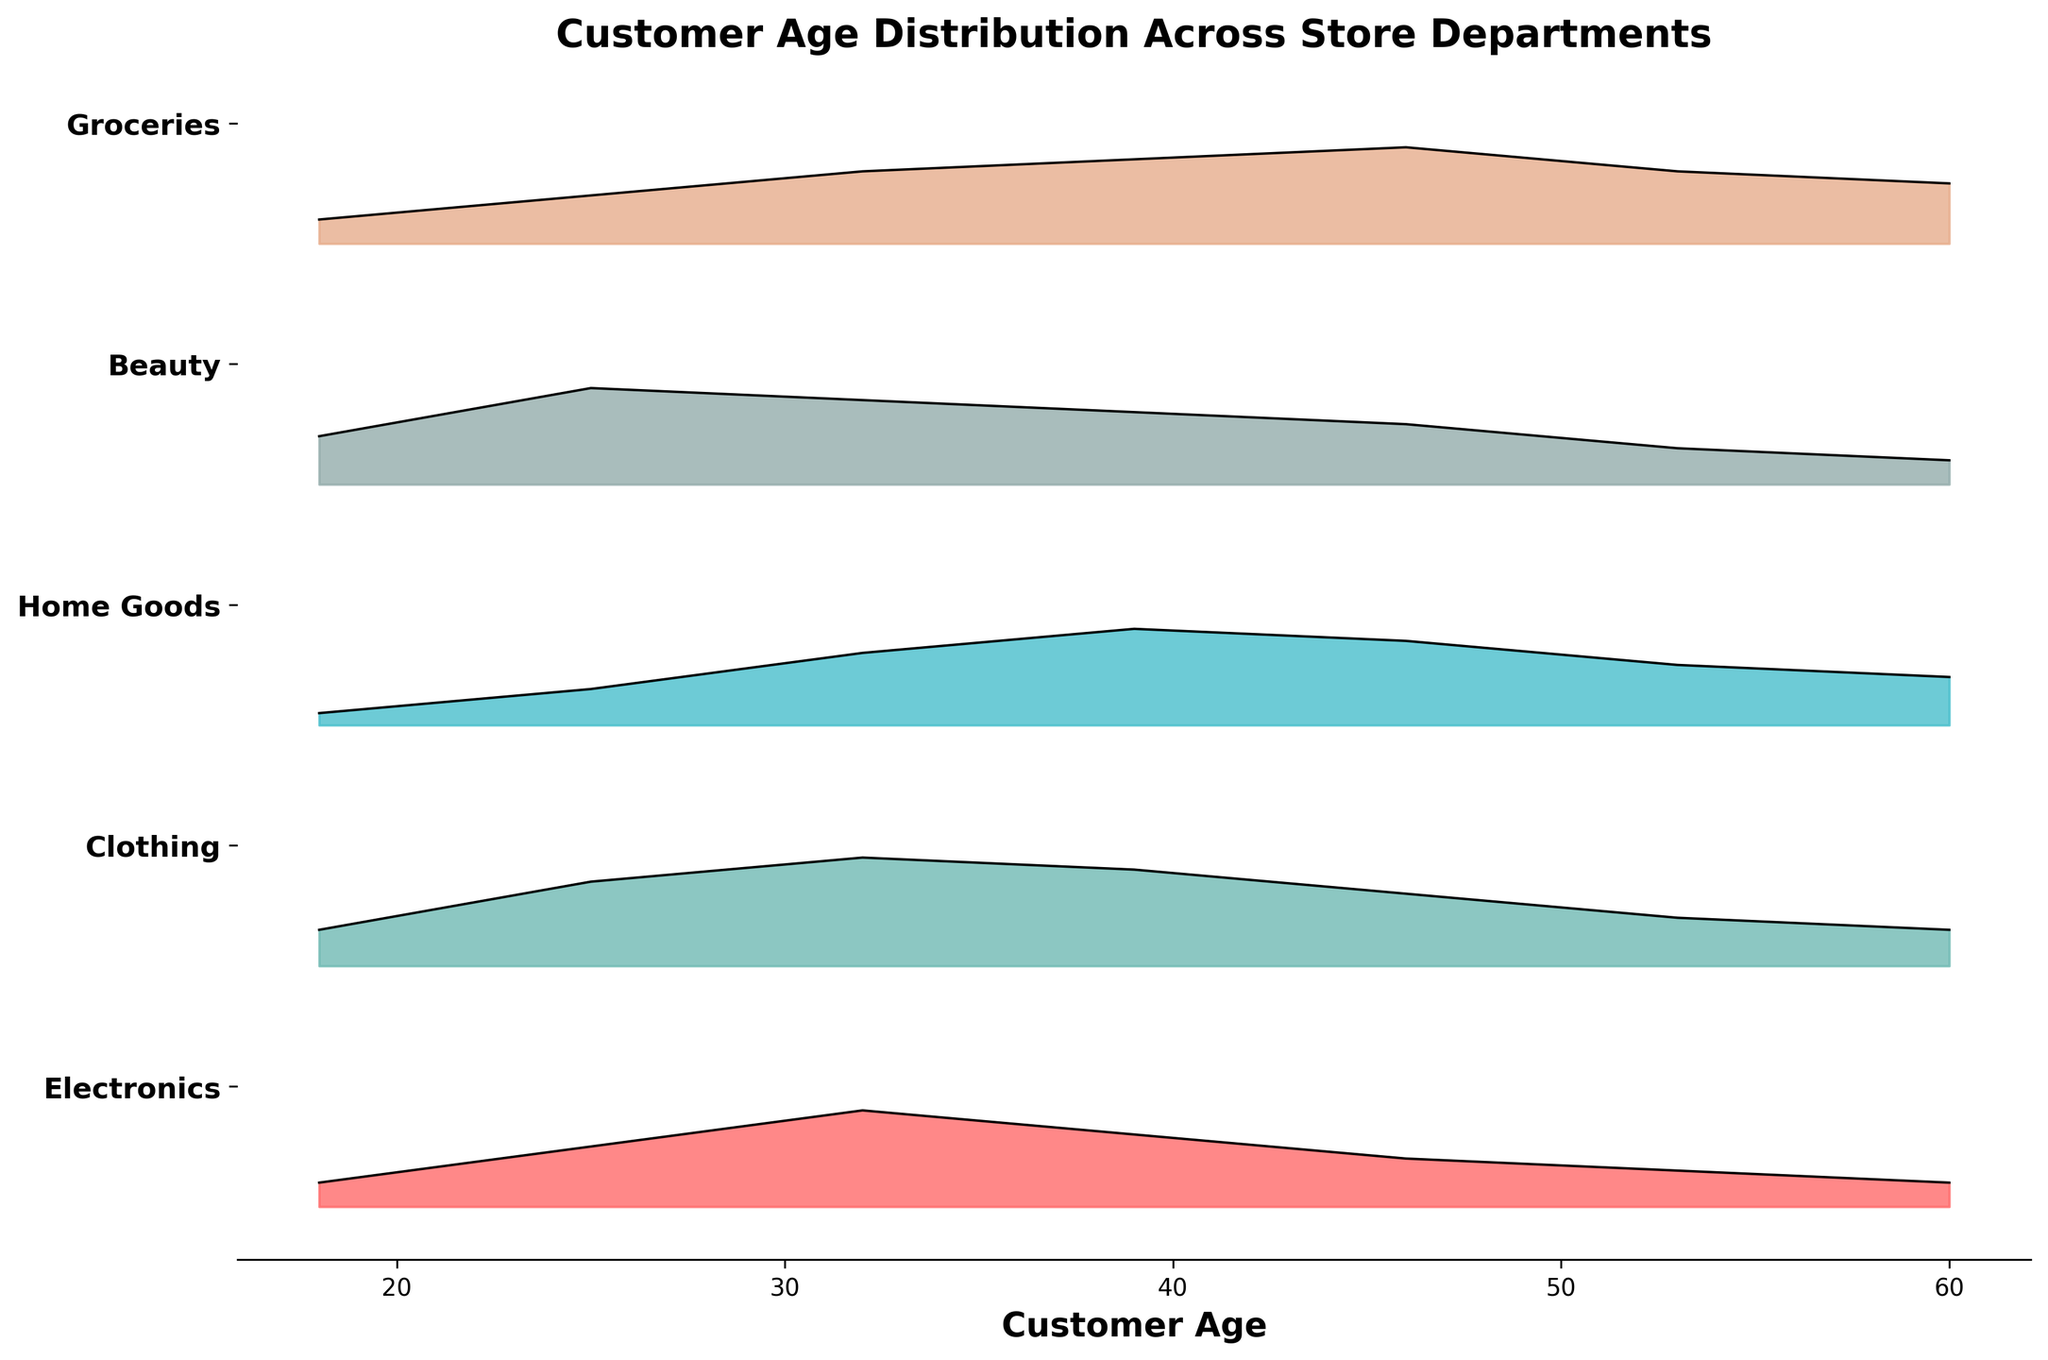What is the title of the figure? The title is usually located at the top of the figure and provides the main description of what the figure is about.
Answer: Customer Age Distribution Across Store Departments What does the x-axis represent? The x-axis is labeled and represents the variable being measured along the horizontal direction in the plot. In this case, it indicates the age of customers.
Answer: Customer Age Which department shows the highest density of customers aged 39? By examining the height of the density curves at age 39, you can identify which department has the highest value.
Answer: Home Goods What is the range of ages displayed in the plot? The x-axis range shows the span of data points representing different age groups in the figure.
Answer: 18 to 60 Which department has the most diverse age distribution of customers? By comparing the spread of age densities across departments, you can determine which one has a more varied customer age range.
Answer: Clothing At what age does the Clothing department have its maximum customer density? The peak of the Clothing department’s density curve indicates the age with the highest density.
Answer: 32 How does the density of customers aged 53 compare between Beauty and Electronics departments? By looking at the density values for age 53 in both departments, you can compare the relative heights.
Answer: Beauty has a higher density than Electronics How many departments have their highest customer density in the 25-39 age range? By identifying the peak ages in the ridgeline plots for each department, you can determine how many fall within this age range.
Answer: 3 (Clothing, Beauty, Groceries) Which department shows the least density variation across different ages? By assessing the relative uniformity of the density curves, you can identify the one with the least fluctuation.
Answer: Groceries 